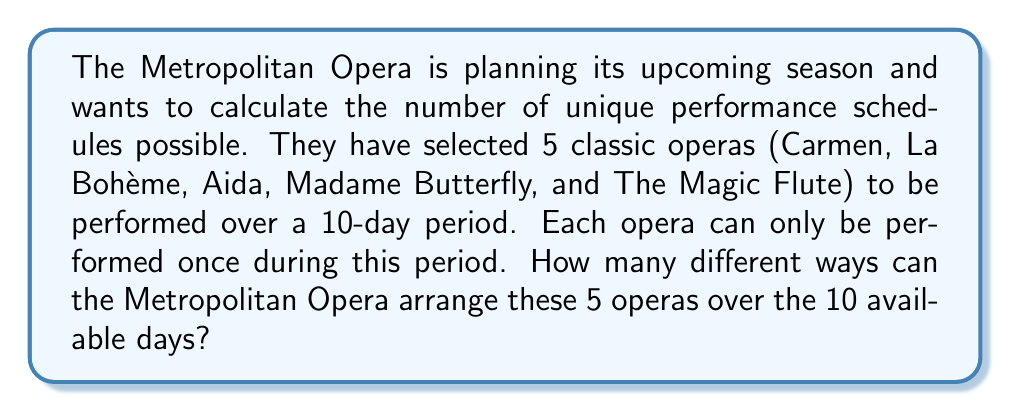Could you help me with this problem? Let's approach this step-by-step:

1) First, we need to recognize that this is a permutation problem. We are selecting 5 days out of 10 to schedule the operas, and then arranging the 5 operas on those selected days.

2) To solve this, we can break it down into two steps:
   a) Choose 5 days out of 10 for the performances
   b) Arrange the 5 operas on these chosen days

3) For step a, we use the combination formula:
   $$\binom{10}{5} = \frac{10!}{5!(10-5)!} = \frac{10!}{5!5!} = 252$$

4) For step b, we need to arrange 5 operas, which is a straightforward permutation:
   $$5! = 5 \times 4 \times 3 \times 2 \times 1 = 120$$

5) By the multiplication principle, the total number of unique schedules is the product of these two results:

   $$252 \times 120 = 30,240$$

Therefore, there are 30,240 different ways to arrange the 5 operas over the 10-day period.
Answer: 30,240 